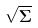<formula> <loc_0><loc_0><loc_500><loc_500>\sqrt { \Sigma }</formula> 